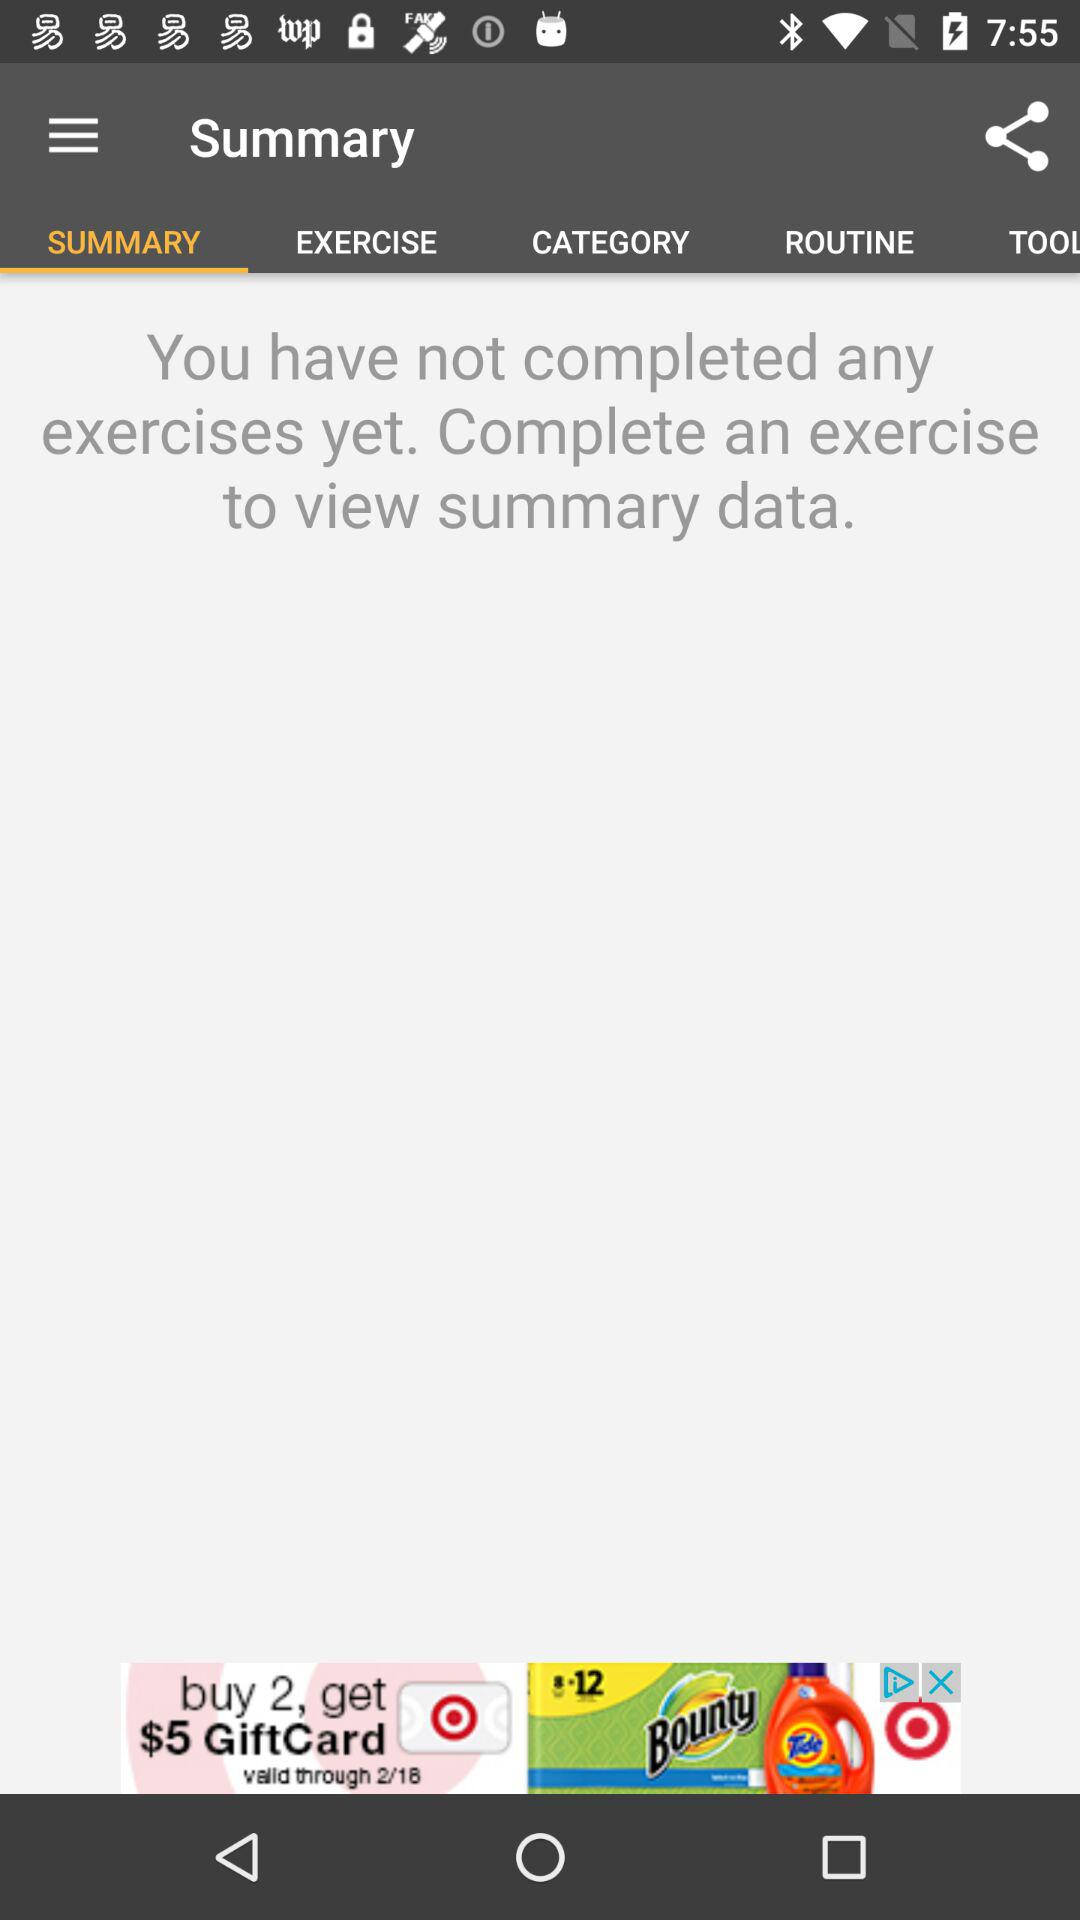How many exercises are completed?
Answer the question using a single word or phrase. 0 